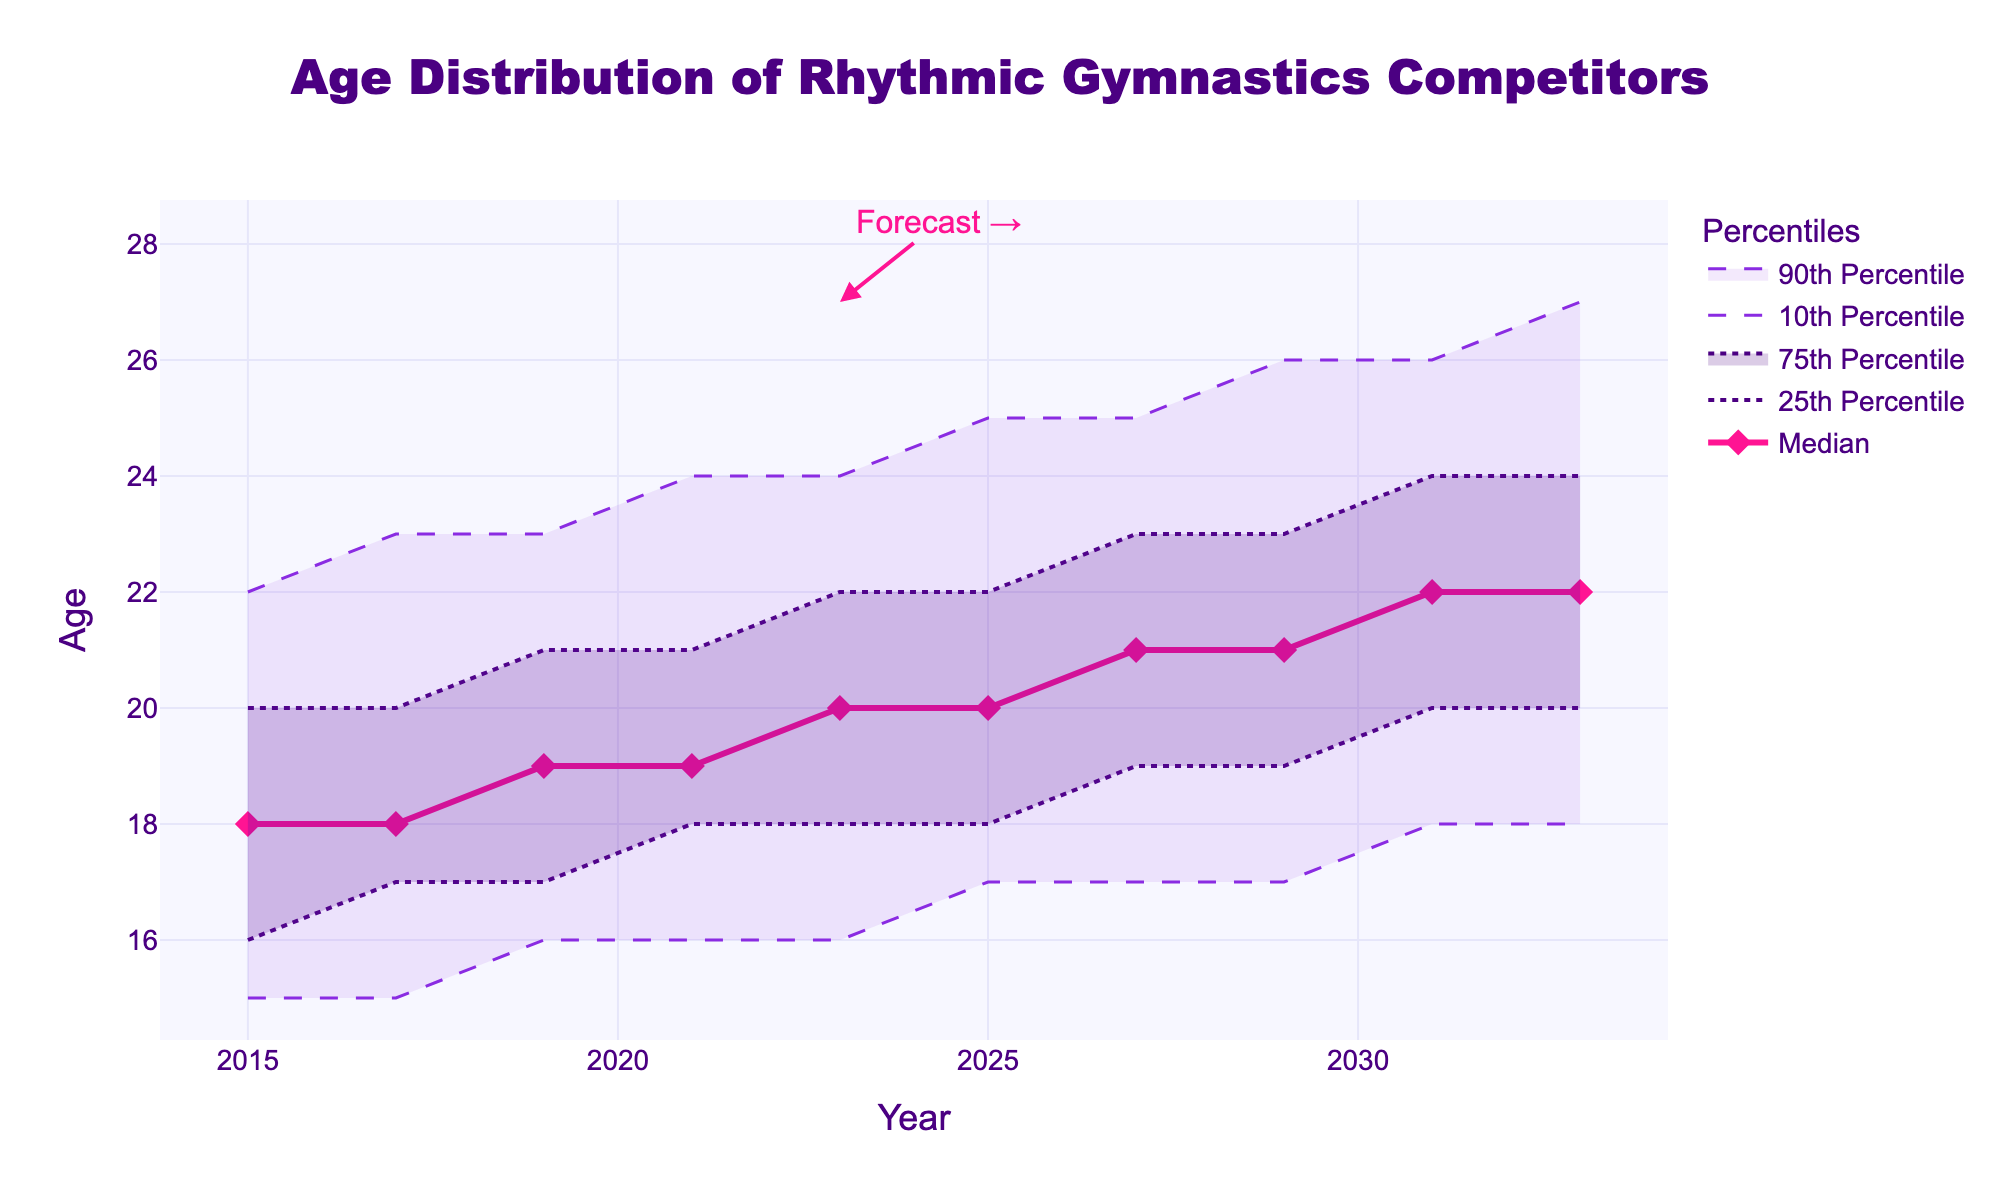What is the median age of rhythmic gymnastics competitors in 2023? The median age can be read directly from the median line corresponding to the year 2023 on the graph, which is labeled on the y-axis.
Answer: 20 What is the range of ages for rhythmic gymnastics competitors in 2019 covered by the 10th to 90th percentile? To determine the range, subtract the 10th percentile value from the 90th percentile value for the year 2019.
Answer: 7 (23 - 16) How has the median age changed from 2015 to 2033? Subtract the median age in 2015 from the median age in 2033 based on the corresponding points on the graph.
Answer: 4 (22 - 18) Which year shows a projected increase in both the 10th and 90th percentiles compared to the previous year? Compare the values in consecutive years along the 10th and 90th percentiles curves and find the year with an increase in both.
Answer: 2027 What is the interquartile range (IQR) of ages in 2025? The IQR can be calculated by subtracting the 25th percentile value from the 75th percentile value for the year 2025.
Answer: 4 (22 - 18) Between 2025 and 2033, what trend does the 25th percentile show? Observe the 25th percentile line between these years and note whether it increases, decreases, or stays the same.
Answer: Increase By how many years does the upper boundary of the 90th percentile increase from 2021 to 2033? Subtract the 90th percentile value in 2021 from that in 2033 using the y-axis values.
Answer: 3 (27 - 24) In what year is the 75th percentile forecast to be 23 years old? Look at the 75th percentile line and find the corresponding year when it hits 23 years old.
Answer: 2027 How much does the median project to increase in the decade after 2023? Subtract the value in 2023 from the projected value in 2033 based on the median line.
Answer: 2 (22 - 20) What is the most noticeable change in the distribution of ages from 2021 to 2023? Examine changes in multiple percentiles (10th, 25th, 75th, and 90th) between these years to identify the most significant change.
Answer: Median increase from 19 to 20 